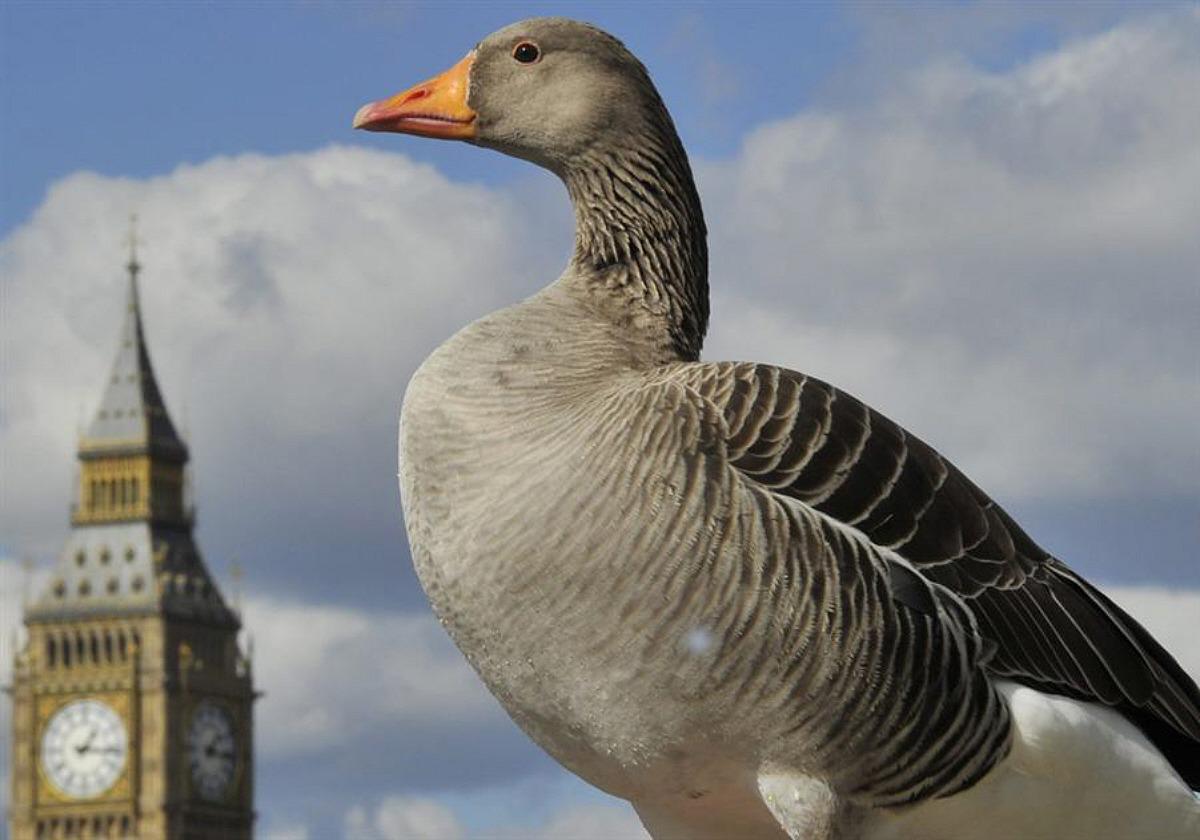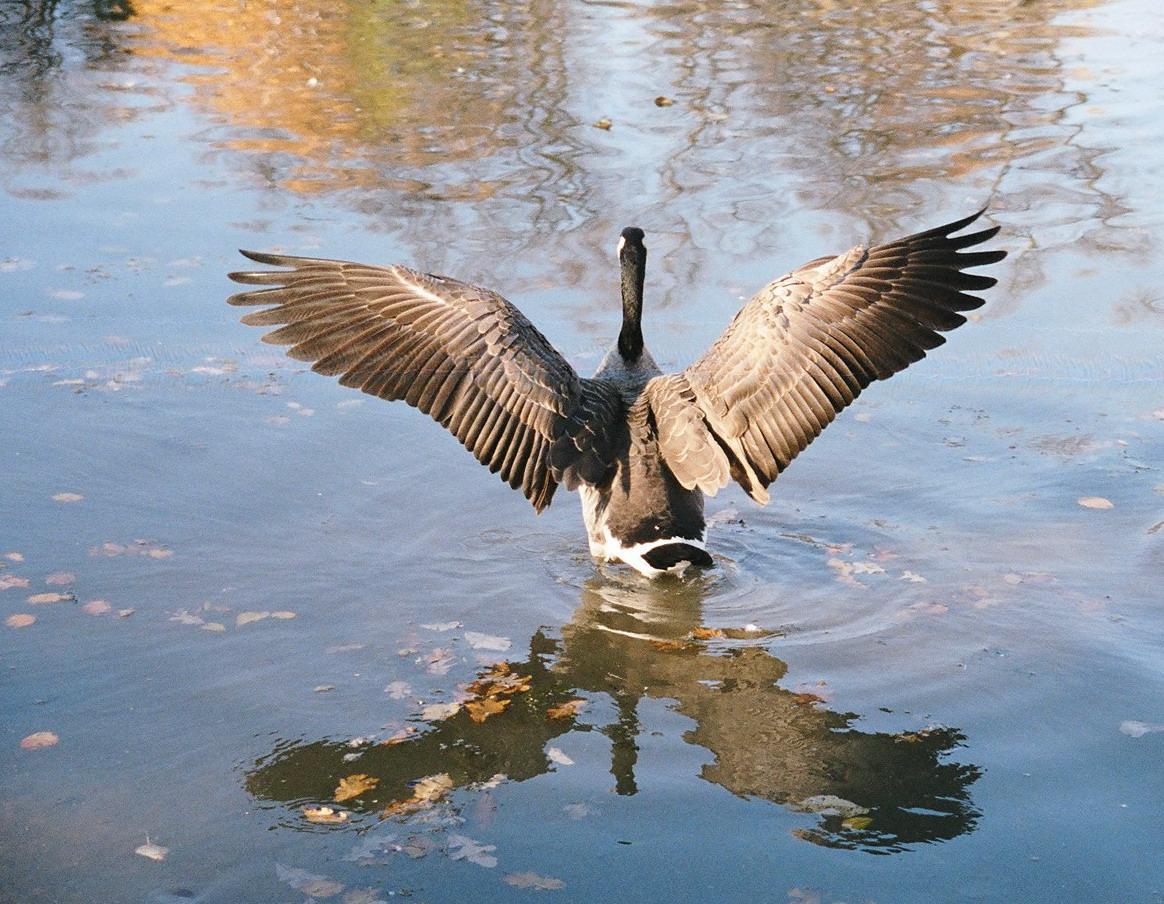The first image is the image on the left, the second image is the image on the right. For the images shown, is this caption "More water fowl are shown in the right image." true? Answer yes or no. No. 